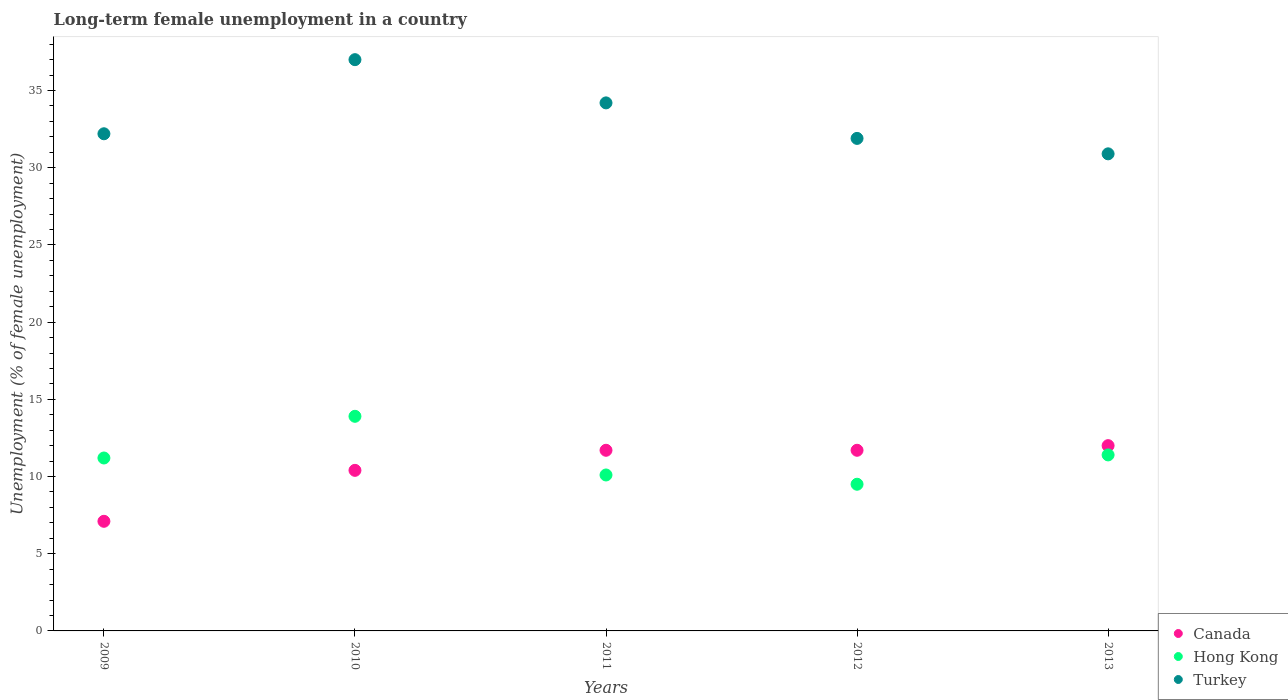How many different coloured dotlines are there?
Provide a succinct answer. 3. Is the number of dotlines equal to the number of legend labels?
Provide a short and direct response. Yes. Across all years, what is the maximum percentage of long-term unemployed female population in Hong Kong?
Offer a very short reply. 13.9. In which year was the percentage of long-term unemployed female population in Canada minimum?
Offer a very short reply. 2009. What is the total percentage of long-term unemployed female population in Hong Kong in the graph?
Keep it short and to the point. 56.1. What is the difference between the percentage of long-term unemployed female population in Canada in 2010 and that in 2011?
Your answer should be compact. -1.3. What is the difference between the percentage of long-term unemployed female population in Turkey in 2013 and the percentage of long-term unemployed female population in Canada in 2009?
Your answer should be very brief. 23.8. What is the average percentage of long-term unemployed female population in Hong Kong per year?
Ensure brevity in your answer.  11.22. In the year 2009, what is the difference between the percentage of long-term unemployed female population in Hong Kong and percentage of long-term unemployed female population in Canada?
Offer a very short reply. 4.1. What is the ratio of the percentage of long-term unemployed female population in Turkey in 2010 to that in 2011?
Offer a terse response. 1.08. What is the difference between the highest and the second highest percentage of long-term unemployed female population in Canada?
Provide a succinct answer. 0.3. What is the difference between the highest and the lowest percentage of long-term unemployed female population in Canada?
Your response must be concise. 4.9. Is the percentage of long-term unemployed female population in Turkey strictly greater than the percentage of long-term unemployed female population in Canada over the years?
Ensure brevity in your answer.  Yes. How many dotlines are there?
Offer a very short reply. 3. How many years are there in the graph?
Give a very brief answer. 5. What is the difference between two consecutive major ticks on the Y-axis?
Offer a very short reply. 5. Does the graph contain any zero values?
Ensure brevity in your answer.  No. Where does the legend appear in the graph?
Your response must be concise. Bottom right. What is the title of the graph?
Your response must be concise. Long-term female unemployment in a country. Does "East Asia (developing only)" appear as one of the legend labels in the graph?
Give a very brief answer. No. What is the label or title of the Y-axis?
Your answer should be very brief. Unemployment (% of female unemployment). What is the Unemployment (% of female unemployment) in Canada in 2009?
Give a very brief answer. 7.1. What is the Unemployment (% of female unemployment) in Hong Kong in 2009?
Ensure brevity in your answer.  11.2. What is the Unemployment (% of female unemployment) of Turkey in 2009?
Your response must be concise. 32.2. What is the Unemployment (% of female unemployment) in Canada in 2010?
Provide a succinct answer. 10.4. What is the Unemployment (% of female unemployment) of Hong Kong in 2010?
Keep it short and to the point. 13.9. What is the Unemployment (% of female unemployment) of Canada in 2011?
Give a very brief answer. 11.7. What is the Unemployment (% of female unemployment) of Hong Kong in 2011?
Ensure brevity in your answer.  10.1. What is the Unemployment (% of female unemployment) in Turkey in 2011?
Make the answer very short. 34.2. What is the Unemployment (% of female unemployment) in Canada in 2012?
Your answer should be compact. 11.7. What is the Unemployment (% of female unemployment) in Hong Kong in 2012?
Your answer should be very brief. 9.5. What is the Unemployment (% of female unemployment) in Turkey in 2012?
Ensure brevity in your answer.  31.9. What is the Unemployment (% of female unemployment) of Canada in 2013?
Make the answer very short. 12. What is the Unemployment (% of female unemployment) in Hong Kong in 2013?
Offer a very short reply. 11.4. What is the Unemployment (% of female unemployment) of Turkey in 2013?
Your response must be concise. 30.9. Across all years, what is the maximum Unemployment (% of female unemployment) in Hong Kong?
Offer a very short reply. 13.9. Across all years, what is the minimum Unemployment (% of female unemployment) in Canada?
Offer a terse response. 7.1. Across all years, what is the minimum Unemployment (% of female unemployment) in Turkey?
Keep it short and to the point. 30.9. What is the total Unemployment (% of female unemployment) in Canada in the graph?
Offer a terse response. 52.9. What is the total Unemployment (% of female unemployment) of Hong Kong in the graph?
Make the answer very short. 56.1. What is the total Unemployment (% of female unemployment) in Turkey in the graph?
Your answer should be very brief. 166.2. What is the difference between the Unemployment (% of female unemployment) in Hong Kong in 2009 and that in 2010?
Offer a very short reply. -2.7. What is the difference between the Unemployment (% of female unemployment) of Turkey in 2009 and that in 2010?
Give a very brief answer. -4.8. What is the difference between the Unemployment (% of female unemployment) in Canada in 2009 and that in 2011?
Your answer should be compact. -4.6. What is the difference between the Unemployment (% of female unemployment) of Hong Kong in 2009 and that in 2011?
Keep it short and to the point. 1.1. What is the difference between the Unemployment (% of female unemployment) of Turkey in 2009 and that in 2011?
Offer a very short reply. -2. What is the difference between the Unemployment (% of female unemployment) in Hong Kong in 2009 and that in 2012?
Offer a very short reply. 1.7. What is the difference between the Unemployment (% of female unemployment) of Turkey in 2009 and that in 2013?
Provide a short and direct response. 1.3. What is the difference between the Unemployment (% of female unemployment) of Canada in 2010 and that in 2011?
Give a very brief answer. -1.3. What is the difference between the Unemployment (% of female unemployment) in Hong Kong in 2010 and that in 2011?
Keep it short and to the point. 3.8. What is the difference between the Unemployment (% of female unemployment) in Turkey in 2010 and that in 2011?
Your response must be concise. 2.8. What is the difference between the Unemployment (% of female unemployment) in Turkey in 2010 and that in 2012?
Provide a short and direct response. 5.1. What is the difference between the Unemployment (% of female unemployment) of Hong Kong in 2010 and that in 2013?
Your response must be concise. 2.5. What is the difference between the Unemployment (% of female unemployment) of Hong Kong in 2011 and that in 2012?
Offer a very short reply. 0.6. What is the difference between the Unemployment (% of female unemployment) of Canada in 2011 and that in 2013?
Provide a succinct answer. -0.3. What is the difference between the Unemployment (% of female unemployment) of Turkey in 2011 and that in 2013?
Give a very brief answer. 3.3. What is the difference between the Unemployment (% of female unemployment) in Turkey in 2012 and that in 2013?
Offer a terse response. 1. What is the difference between the Unemployment (% of female unemployment) of Canada in 2009 and the Unemployment (% of female unemployment) of Hong Kong in 2010?
Provide a short and direct response. -6.8. What is the difference between the Unemployment (% of female unemployment) of Canada in 2009 and the Unemployment (% of female unemployment) of Turkey in 2010?
Your answer should be very brief. -29.9. What is the difference between the Unemployment (% of female unemployment) of Hong Kong in 2009 and the Unemployment (% of female unemployment) of Turkey in 2010?
Your answer should be very brief. -25.8. What is the difference between the Unemployment (% of female unemployment) in Canada in 2009 and the Unemployment (% of female unemployment) in Hong Kong in 2011?
Provide a short and direct response. -3. What is the difference between the Unemployment (% of female unemployment) in Canada in 2009 and the Unemployment (% of female unemployment) in Turkey in 2011?
Provide a succinct answer. -27.1. What is the difference between the Unemployment (% of female unemployment) in Canada in 2009 and the Unemployment (% of female unemployment) in Hong Kong in 2012?
Offer a terse response. -2.4. What is the difference between the Unemployment (% of female unemployment) in Canada in 2009 and the Unemployment (% of female unemployment) in Turkey in 2012?
Your response must be concise. -24.8. What is the difference between the Unemployment (% of female unemployment) of Hong Kong in 2009 and the Unemployment (% of female unemployment) of Turkey in 2012?
Your answer should be compact. -20.7. What is the difference between the Unemployment (% of female unemployment) in Canada in 2009 and the Unemployment (% of female unemployment) in Turkey in 2013?
Your answer should be very brief. -23.8. What is the difference between the Unemployment (% of female unemployment) in Hong Kong in 2009 and the Unemployment (% of female unemployment) in Turkey in 2013?
Offer a very short reply. -19.7. What is the difference between the Unemployment (% of female unemployment) in Canada in 2010 and the Unemployment (% of female unemployment) in Turkey in 2011?
Keep it short and to the point. -23.8. What is the difference between the Unemployment (% of female unemployment) of Hong Kong in 2010 and the Unemployment (% of female unemployment) of Turkey in 2011?
Provide a short and direct response. -20.3. What is the difference between the Unemployment (% of female unemployment) of Canada in 2010 and the Unemployment (% of female unemployment) of Turkey in 2012?
Your answer should be very brief. -21.5. What is the difference between the Unemployment (% of female unemployment) in Canada in 2010 and the Unemployment (% of female unemployment) in Turkey in 2013?
Keep it short and to the point. -20.5. What is the difference between the Unemployment (% of female unemployment) of Canada in 2011 and the Unemployment (% of female unemployment) of Turkey in 2012?
Your answer should be very brief. -20.2. What is the difference between the Unemployment (% of female unemployment) of Hong Kong in 2011 and the Unemployment (% of female unemployment) of Turkey in 2012?
Provide a short and direct response. -21.8. What is the difference between the Unemployment (% of female unemployment) of Canada in 2011 and the Unemployment (% of female unemployment) of Hong Kong in 2013?
Make the answer very short. 0.3. What is the difference between the Unemployment (% of female unemployment) of Canada in 2011 and the Unemployment (% of female unemployment) of Turkey in 2013?
Keep it short and to the point. -19.2. What is the difference between the Unemployment (% of female unemployment) in Hong Kong in 2011 and the Unemployment (% of female unemployment) in Turkey in 2013?
Offer a terse response. -20.8. What is the difference between the Unemployment (% of female unemployment) in Canada in 2012 and the Unemployment (% of female unemployment) in Hong Kong in 2013?
Offer a terse response. 0.3. What is the difference between the Unemployment (% of female unemployment) of Canada in 2012 and the Unemployment (% of female unemployment) of Turkey in 2013?
Provide a succinct answer. -19.2. What is the difference between the Unemployment (% of female unemployment) in Hong Kong in 2012 and the Unemployment (% of female unemployment) in Turkey in 2013?
Keep it short and to the point. -21.4. What is the average Unemployment (% of female unemployment) in Canada per year?
Your answer should be compact. 10.58. What is the average Unemployment (% of female unemployment) in Hong Kong per year?
Make the answer very short. 11.22. What is the average Unemployment (% of female unemployment) of Turkey per year?
Ensure brevity in your answer.  33.24. In the year 2009, what is the difference between the Unemployment (% of female unemployment) of Canada and Unemployment (% of female unemployment) of Turkey?
Offer a terse response. -25.1. In the year 2009, what is the difference between the Unemployment (% of female unemployment) of Hong Kong and Unemployment (% of female unemployment) of Turkey?
Keep it short and to the point. -21. In the year 2010, what is the difference between the Unemployment (% of female unemployment) of Canada and Unemployment (% of female unemployment) of Hong Kong?
Offer a terse response. -3.5. In the year 2010, what is the difference between the Unemployment (% of female unemployment) in Canada and Unemployment (% of female unemployment) in Turkey?
Offer a terse response. -26.6. In the year 2010, what is the difference between the Unemployment (% of female unemployment) of Hong Kong and Unemployment (% of female unemployment) of Turkey?
Offer a terse response. -23.1. In the year 2011, what is the difference between the Unemployment (% of female unemployment) of Canada and Unemployment (% of female unemployment) of Turkey?
Your response must be concise. -22.5. In the year 2011, what is the difference between the Unemployment (% of female unemployment) of Hong Kong and Unemployment (% of female unemployment) of Turkey?
Provide a short and direct response. -24.1. In the year 2012, what is the difference between the Unemployment (% of female unemployment) of Canada and Unemployment (% of female unemployment) of Hong Kong?
Your response must be concise. 2.2. In the year 2012, what is the difference between the Unemployment (% of female unemployment) of Canada and Unemployment (% of female unemployment) of Turkey?
Provide a succinct answer. -20.2. In the year 2012, what is the difference between the Unemployment (% of female unemployment) of Hong Kong and Unemployment (% of female unemployment) of Turkey?
Provide a short and direct response. -22.4. In the year 2013, what is the difference between the Unemployment (% of female unemployment) of Canada and Unemployment (% of female unemployment) of Hong Kong?
Provide a succinct answer. 0.6. In the year 2013, what is the difference between the Unemployment (% of female unemployment) of Canada and Unemployment (% of female unemployment) of Turkey?
Your answer should be compact. -18.9. In the year 2013, what is the difference between the Unemployment (% of female unemployment) of Hong Kong and Unemployment (% of female unemployment) of Turkey?
Offer a terse response. -19.5. What is the ratio of the Unemployment (% of female unemployment) of Canada in 2009 to that in 2010?
Ensure brevity in your answer.  0.68. What is the ratio of the Unemployment (% of female unemployment) in Hong Kong in 2009 to that in 2010?
Provide a short and direct response. 0.81. What is the ratio of the Unemployment (% of female unemployment) in Turkey in 2009 to that in 2010?
Offer a very short reply. 0.87. What is the ratio of the Unemployment (% of female unemployment) in Canada in 2009 to that in 2011?
Offer a very short reply. 0.61. What is the ratio of the Unemployment (% of female unemployment) of Hong Kong in 2009 to that in 2011?
Make the answer very short. 1.11. What is the ratio of the Unemployment (% of female unemployment) in Turkey in 2009 to that in 2011?
Provide a succinct answer. 0.94. What is the ratio of the Unemployment (% of female unemployment) in Canada in 2009 to that in 2012?
Provide a short and direct response. 0.61. What is the ratio of the Unemployment (% of female unemployment) in Hong Kong in 2009 to that in 2012?
Make the answer very short. 1.18. What is the ratio of the Unemployment (% of female unemployment) in Turkey in 2009 to that in 2012?
Ensure brevity in your answer.  1.01. What is the ratio of the Unemployment (% of female unemployment) in Canada in 2009 to that in 2013?
Your answer should be compact. 0.59. What is the ratio of the Unemployment (% of female unemployment) in Hong Kong in 2009 to that in 2013?
Ensure brevity in your answer.  0.98. What is the ratio of the Unemployment (% of female unemployment) of Turkey in 2009 to that in 2013?
Give a very brief answer. 1.04. What is the ratio of the Unemployment (% of female unemployment) in Canada in 2010 to that in 2011?
Offer a very short reply. 0.89. What is the ratio of the Unemployment (% of female unemployment) in Hong Kong in 2010 to that in 2011?
Give a very brief answer. 1.38. What is the ratio of the Unemployment (% of female unemployment) of Turkey in 2010 to that in 2011?
Provide a succinct answer. 1.08. What is the ratio of the Unemployment (% of female unemployment) of Hong Kong in 2010 to that in 2012?
Make the answer very short. 1.46. What is the ratio of the Unemployment (% of female unemployment) in Turkey in 2010 to that in 2012?
Your answer should be compact. 1.16. What is the ratio of the Unemployment (% of female unemployment) of Canada in 2010 to that in 2013?
Your answer should be very brief. 0.87. What is the ratio of the Unemployment (% of female unemployment) of Hong Kong in 2010 to that in 2013?
Make the answer very short. 1.22. What is the ratio of the Unemployment (% of female unemployment) of Turkey in 2010 to that in 2013?
Offer a very short reply. 1.2. What is the ratio of the Unemployment (% of female unemployment) in Canada in 2011 to that in 2012?
Offer a terse response. 1. What is the ratio of the Unemployment (% of female unemployment) in Hong Kong in 2011 to that in 2012?
Give a very brief answer. 1.06. What is the ratio of the Unemployment (% of female unemployment) in Turkey in 2011 to that in 2012?
Provide a short and direct response. 1.07. What is the ratio of the Unemployment (% of female unemployment) in Canada in 2011 to that in 2013?
Make the answer very short. 0.97. What is the ratio of the Unemployment (% of female unemployment) in Hong Kong in 2011 to that in 2013?
Ensure brevity in your answer.  0.89. What is the ratio of the Unemployment (% of female unemployment) in Turkey in 2011 to that in 2013?
Your response must be concise. 1.11. What is the ratio of the Unemployment (% of female unemployment) in Canada in 2012 to that in 2013?
Your answer should be very brief. 0.97. What is the ratio of the Unemployment (% of female unemployment) of Turkey in 2012 to that in 2013?
Give a very brief answer. 1.03. What is the difference between the highest and the second highest Unemployment (% of female unemployment) in Hong Kong?
Offer a terse response. 2.5. What is the difference between the highest and the second highest Unemployment (% of female unemployment) of Turkey?
Ensure brevity in your answer.  2.8. What is the difference between the highest and the lowest Unemployment (% of female unemployment) in Hong Kong?
Offer a terse response. 4.4. What is the difference between the highest and the lowest Unemployment (% of female unemployment) in Turkey?
Make the answer very short. 6.1. 